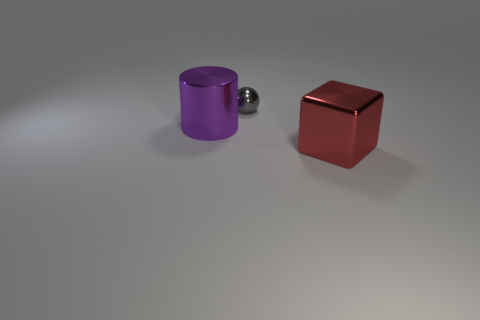There is a metallic thing that is to the left of the metal thing behind the large metal object left of the metallic cube; what color is it?
Your response must be concise. Purple. What number of matte objects are either big red things or tiny gray spheres?
Make the answer very short. 0. Is the number of things to the left of the small gray shiny sphere greater than the number of tiny objects that are to the left of the cylinder?
Your answer should be very brief. Yes. How many other things are there of the same size as the sphere?
Offer a terse response. 0. What size is the object behind the shiny object left of the tiny metal sphere?
Provide a short and direct response. Small. What number of tiny objects are either brown rubber things or purple objects?
Ensure brevity in your answer.  0. What size is the metallic thing that is behind the big shiny object on the left side of the big object that is to the right of the purple metallic object?
Make the answer very short. Small. What number of shiny things are on the right side of the purple metal cylinder and in front of the small gray metal sphere?
Your response must be concise. 1. What color is the large shiny thing to the left of the metal thing that is right of the gray ball?
Make the answer very short. Purple. Is the number of red shiny cubes behind the small thing the same as the number of gray things?
Provide a succinct answer. No. 